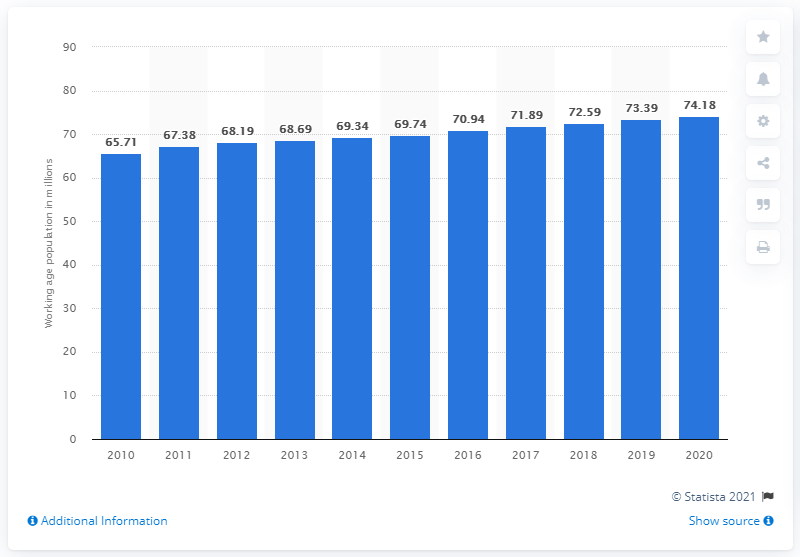Give some essential details in this illustration. In 2020, the working-age population in Vietnam was 74.18 million. In 2020, the working age population of Vietnam was estimated to be approximately 74.18 million people. 